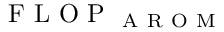<formula> <loc_0><loc_0><loc_500><loc_500>F L O P _ { A R O M }</formula> 